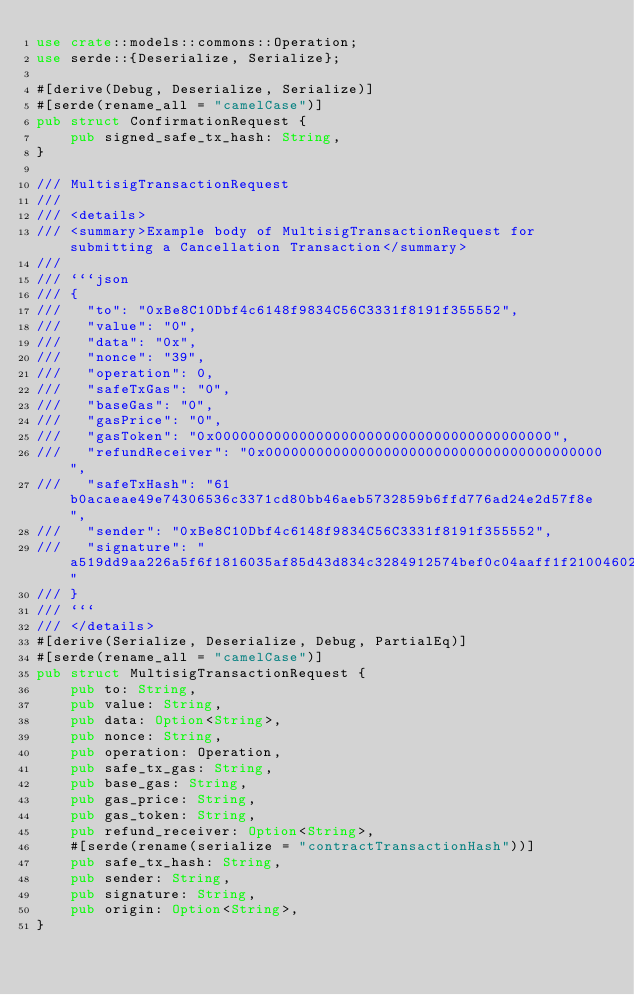<code> <loc_0><loc_0><loc_500><loc_500><_Rust_>use crate::models::commons::Operation;
use serde::{Deserialize, Serialize};

#[derive(Debug, Deserialize, Serialize)]
#[serde(rename_all = "camelCase")]
pub struct ConfirmationRequest {
    pub signed_safe_tx_hash: String,
}

/// MultisigTransactionRequest
///
/// <details>
/// <summary>Example body of MultisigTransactionRequest for submitting a Cancellation Transaction</summary>
///
/// ```json
/// {
///   "to": "0xBe8C10Dbf4c6148f9834C56C3331f8191f355552",
///   "value": "0",
///   "data": "0x",
///   "nonce": "39",
///   "operation": 0,
///   "safeTxGas": "0",
///   "baseGas": "0",
///   "gasPrice": "0",
///   "gasToken": "0x0000000000000000000000000000000000000000",
///   "refundReceiver": "0x0000000000000000000000000000000000000000",
///   "safeTxHash": "61b0acaeae49e74306536c3371cd80bb46aeb5732859b6ffd776ad24e2d57f8e",
///   "sender": "0xBe8C10Dbf4c6148f9834C56C3331f8191f355552",
///   "signature": "a519dd9aa226a5f6f1816035af85d43d834c3284912574bef0c04aaff1f21004602a5339da424cf53de9aac068f67a3417f3cba40e3049637ae901b6f345b4ac1b"
/// }
/// ```
/// </details>
#[derive(Serialize, Deserialize, Debug, PartialEq)]
#[serde(rename_all = "camelCase")]
pub struct MultisigTransactionRequest {
    pub to: String,
    pub value: String,
    pub data: Option<String>,
    pub nonce: String,
    pub operation: Operation,
    pub safe_tx_gas: String,
    pub base_gas: String,
    pub gas_price: String,
    pub gas_token: String,
    pub refund_receiver: Option<String>,
    #[serde(rename(serialize = "contractTransactionHash"))]
    pub safe_tx_hash: String,
    pub sender: String,
    pub signature: String,
    pub origin: Option<String>,
}
</code> 